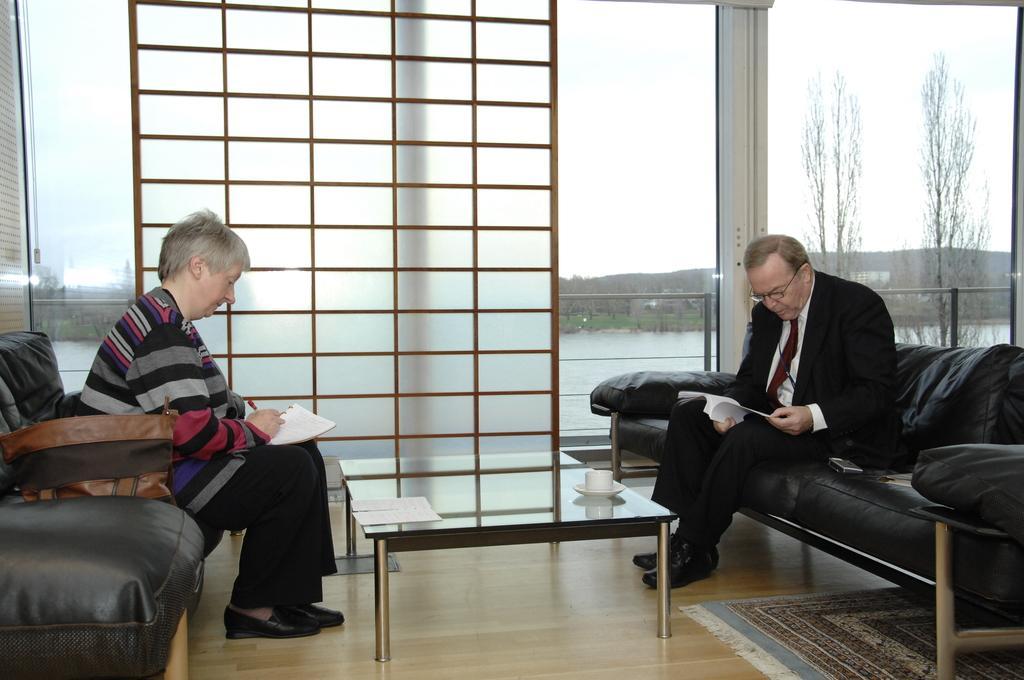Describe this image in one or two sentences. In the foreground of this image, on either side, there is a man and a woman sitting on the couch and holding papers. The woman is holding a pen and beside her, there is a bag. In front of them, there is a table on which, there is a cup, saucer and few papers. At the bottom, there is a mat. In the background, there is a glass door, railing, trees, water and the sky. 